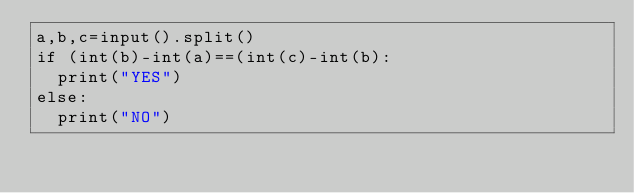<code> <loc_0><loc_0><loc_500><loc_500><_Python_>a,b,c=input().split()
if (int(b)-int(a)==(int(c)-int(b):
	print("YES")
else:
	print("NO")</code> 